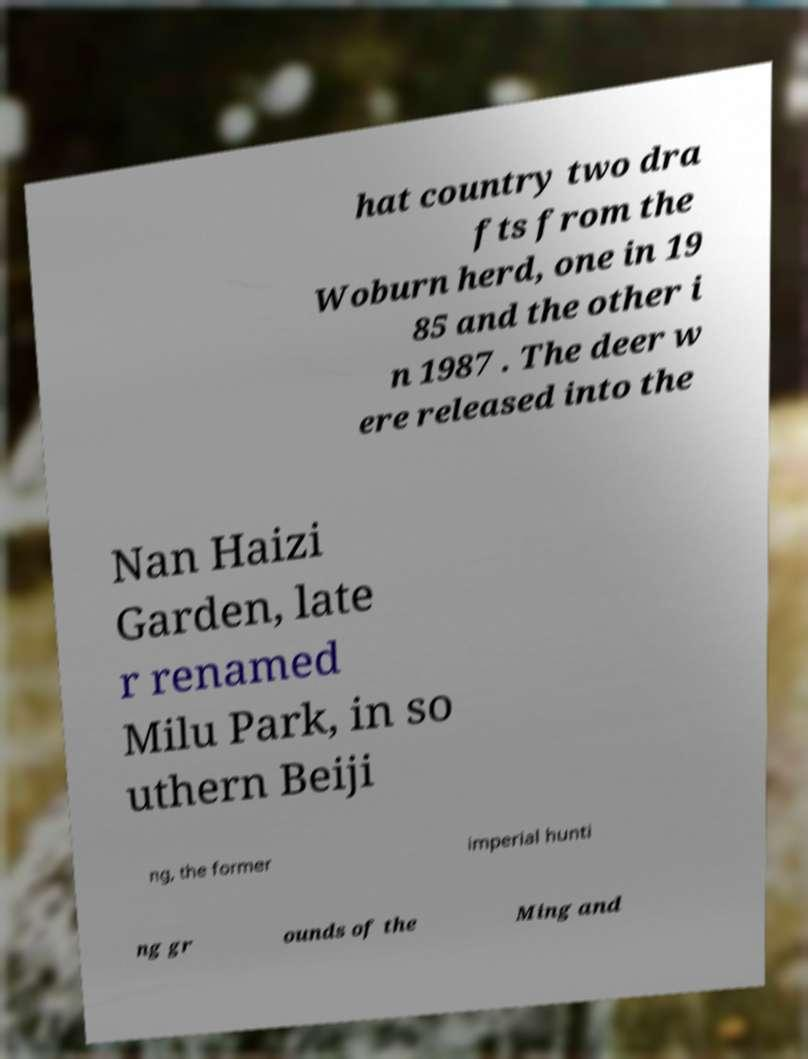Please read and relay the text visible in this image. What does it say? hat country two dra fts from the Woburn herd, one in 19 85 and the other i n 1987 . The deer w ere released into the Nan Haizi Garden, late r renamed Milu Park, in so uthern Beiji ng, the former imperial hunti ng gr ounds of the Ming and 